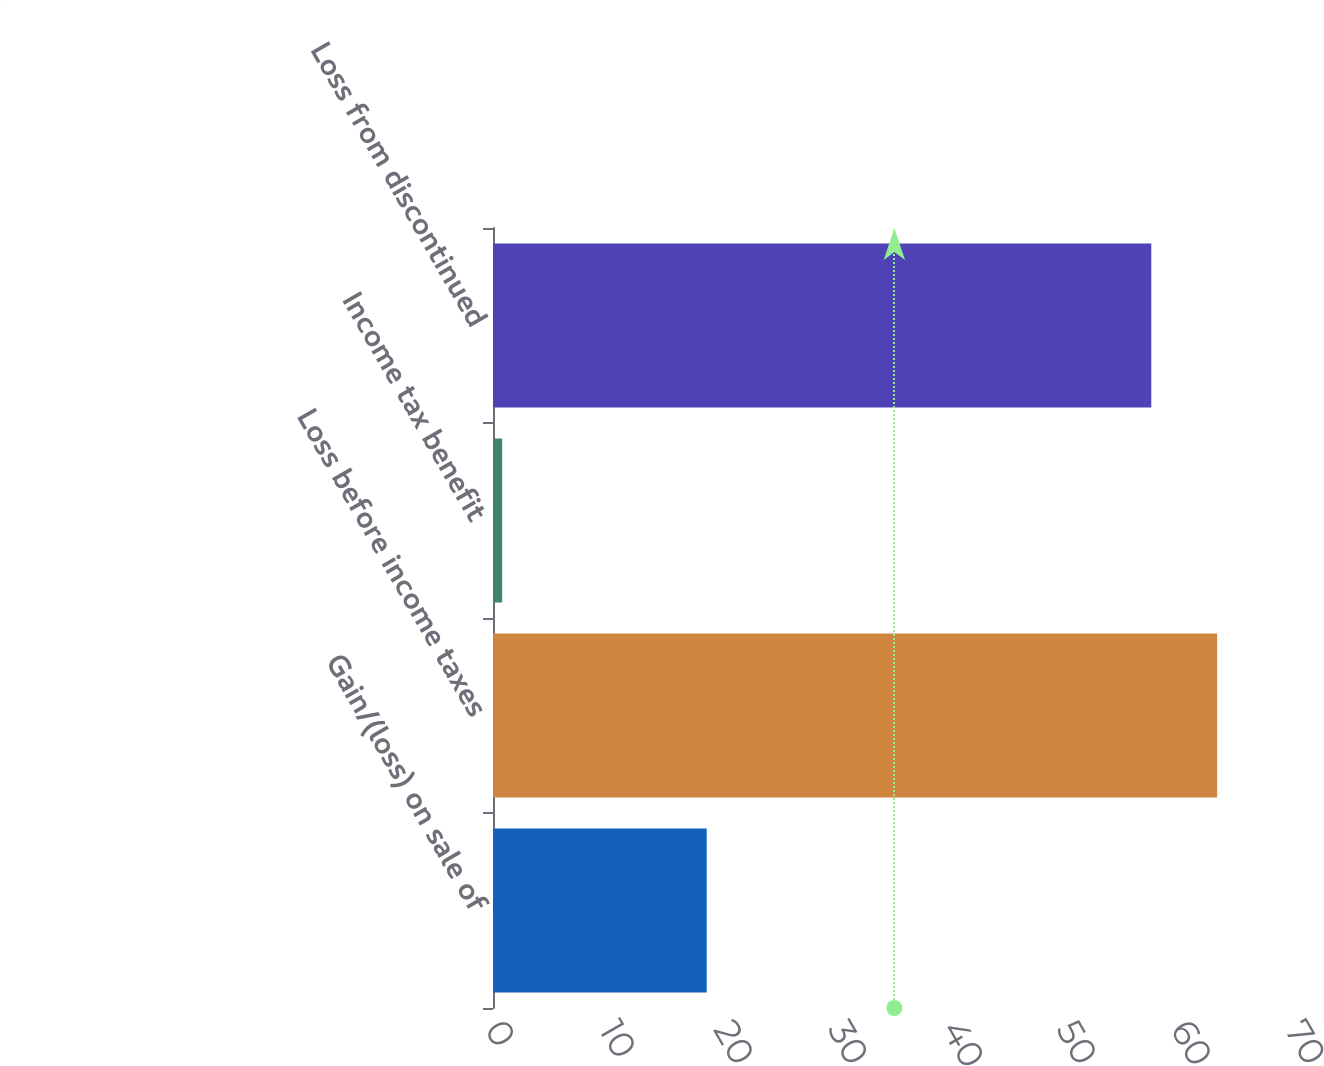Convert chart to OTSL. <chart><loc_0><loc_0><loc_500><loc_500><bar_chart><fcel>Gain/(loss) on sale of<fcel>Loss before income taxes<fcel>Income tax benefit<fcel>Loss from discontinued<nl><fcel>18.7<fcel>63.36<fcel>0.8<fcel>57.6<nl></chart> 